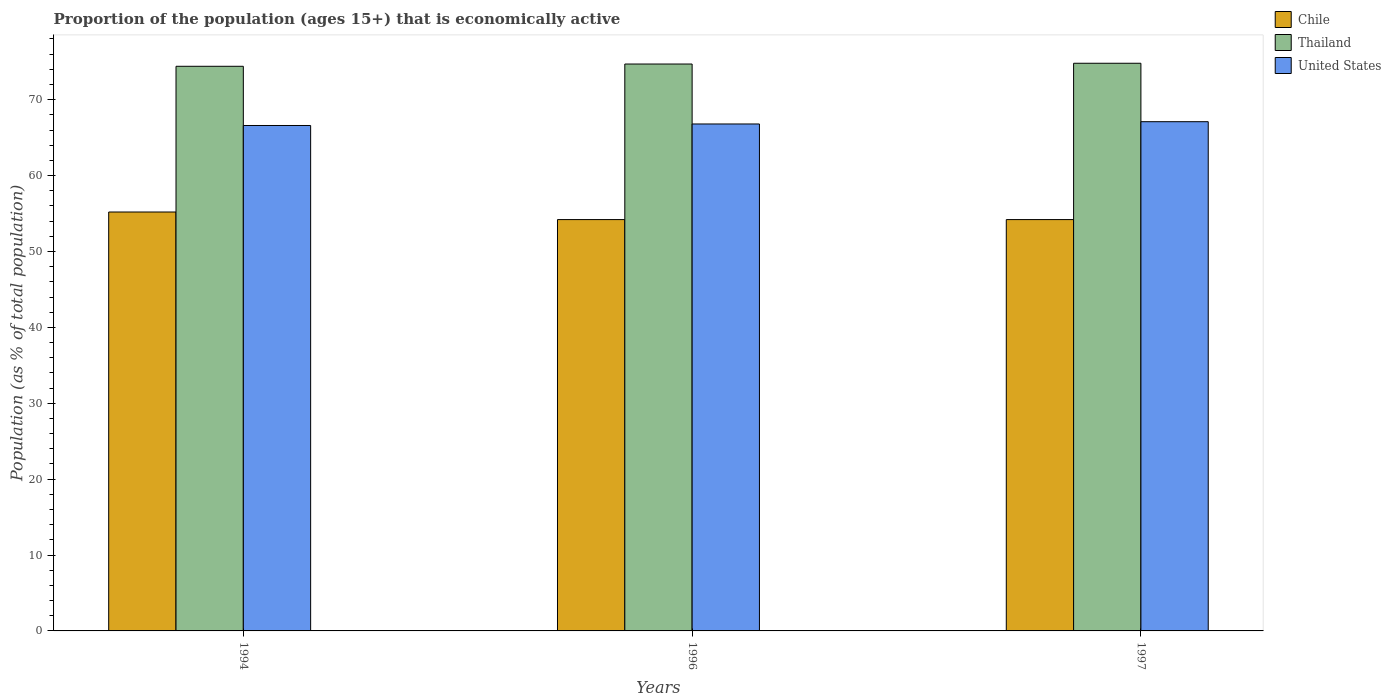How many different coloured bars are there?
Keep it short and to the point. 3. How many bars are there on the 1st tick from the left?
Offer a very short reply. 3. In how many cases, is the number of bars for a given year not equal to the number of legend labels?
Provide a succinct answer. 0. What is the proportion of the population that is economically active in Thailand in 1997?
Your response must be concise. 74.8. Across all years, what is the maximum proportion of the population that is economically active in Chile?
Your answer should be very brief. 55.2. Across all years, what is the minimum proportion of the population that is economically active in Thailand?
Provide a succinct answer. 74.4. In which year was the proportion of the population that is economically active in United States maximum?
Keep it short and to the point. 1997. In which year was the proportion of the population that is economically active in Thailand minimum?
Make the answer very short. 1994. What is the total proportion of the population that is economically active in Chile in the graph?
Offer a very short reply. 163.6. What is the difference between the proportion of the population that is economically active in United States in 1996 and that in 1997?
Give a very brief answer. -0.3. What is the difference between the proportion of the population that is economically active in Thailand in 1997 and the proportion of the population that is economically active in Chile in 1994?
Give a very brief answer. 19.6. What is the average proportion of the population that is economically active in Chile per year?
Make the answer very short. 54.53. In the year 1994, what is the difference between the proportion of the population that is economically active in Chile and proportion of the population that is economically active in Thailand?
Keep it short and to the point. -19.2. In how many years, is the proportion of the population that is economically active in United States greater than 68 %?
Provide a short and direct response. 0. Is the proportion of the population that is economically active in Chile in 1996 less than that in 1997?
Provide a succinct answer. No. What is the difference between the highest and the second highest proportion of the population that is economically active in United States?
Your answer should be very brief. 0.3. In how many years, is the proportion of the population that is economically active in Thailand greater than the average proportion of the population that is economically active in Thailand taken over all years?
Your answer should be very brief. 2. Is the sum of the proportion of the population that is economically active in Chile in 1994 and 1996 greater than the maximum proportion of the population that is economically active in United States across all years?
Make the answer very short. Yes. What does the 2nd bar from the left in 1994 represents?
Your answer should be very brief. Thailand. What does the 1st bar from the right in 1996 represents?
Ensure brevity in your answer.  United States. Is it the case that in every year, the sum of the proportion of the population that is economically active in United States and proportion of the population that is economically active in Chile is greater than the proportion of the population that is economically active in Thailand?
Make the answer very short. Yes. How many bars are there?
Give a very brief answer. 9. How many years are there in the graph?
Your answer should be compact. 3. What is the difference between two consecutive major ticks on the Y-axis?
Keep it short and to the point. 10. Are the values on the major ticks of Y-axis written in scientific E-notation?
Provide a succinct answer. No. How are the legend labels stacked?
Keep it short and to the point. Vertical. What is the title of the graph?
Offer a very short reply. Proportion of the population (ages 15+) that is economically active. Does "Channel Islands" appear as one of the legend labels in the graph?
Your answer should be very brief. No. What is the label or title of the Y-axis?
Your answer should be compact. Population (as % of total population). What is the Population (as % of total population) in Chile in 1994?
Offer a terse response. 55.2. What is the Population (as % of total population) of Thailand in 1994?
Offer a terse response. 74.4. What is the Population (as % of total population) of United States in 1994?
Provide a short and direct response. 66.6. What is the Population (as % of total population) in Chile in 1996?
Your answer should be very brief. 54.2. What is the Population (as % of total population) in Thailand in 1996?
Make the answer very short. 74.7. What is the Population (as % of total population) of United States in 1996?
Your response must be concise. 66.8. What is the Population (as % of total population) in Chile in 1997?
Your response must be concise. 54.2. What is the Population (as % of total population) in Thailand in 1997?
Provide a succinct answer. 74.8. What is the Population (as % of total population) in United States in 1997?
Offer a terse response. 67.1. Across all years, what is the maximum Population (as % of total population) in Chile?
Offer a very short reply. 55.2. Across all years, what is the maximum Population (as % of total population) in Thailand?
Keep it short and to the point. 74.8. Across all years, what is the maximum Population (as % of total population) in United States?
Make the answer very short. 67.1. Across all years, what is the minimum Population (as % of total population) of Chile?
Offer a very short reply. 54.2. Across all years, what is the minimum Population (as % of total population) of Thailand?
Offer a very short reply. 74.4. Across all years, what is the minimum Population (as % of total population) in United States?
Make the answer very short. 66.6. What is the total Population (as % of total population) of Chile in the graph?
Provide a short and direct response. 163.6. What is the total Population (as % of total population) in Thailand in the graph?
Provide a short and direct response. 223.9. What is the total Population (as % of total population) of United States in the graph?
Give a very brief answer. 200.5. What is the difference between the Population (as % of total population) in Chile in 1994 and that in 1996?
Ensure brevity in your answer.  1. What is the difference between the Population (as % of total population) of Chile in 1994 and that in 1997?
Keep it short and to the point. 1. What is the difference between the Population (as % of total population) in United States in 1994 and that in 1997?
Provide a short and direct response. -0.5. What is the difference between the Population (as % of total population) of Chile in 1996 and that in 1997?
Provide a short and direct response. 0. What is the difference between the Population (as % of total population) of Thailand in 1996 and that in 1997?
Make the answer very short. -0.1. What is the difference between the Population (as % of total population) of United States in 1996 and that in 1997?
Make the answer very short. -0.3. What is the difference between the Population (as % of total population) of Chile in 1994 and the Population (as % of total population) of Thailand in 1996?
Make the answer very short. -19.5. What is the difference between the Population (as % of total population) of Chile in 1994 and the Population (as % of total population) of Thailand in 1997?
Keep it short and to the point. -19.6. What is the difference between the Population (as % of total population) in Chile in 1994 and the Population (as % of total population) in United States in 1997?
Give a very brief answer. -11.9. What is the difference between the Population (as % of total population) in Thailand in 1994 and the Population (as % of total population) in United States in 1997?
Your answer should be compact. 7.3. What is the difference between the Population (as % of total population) in Chile in 1996 and the Population (as % of total population) in Thailand in 1997?
Offer a very short reply. -20.6. What is the difference between the Population (as % of total population) in Chile in 1996 and the Population (as % of total population) in United States in 1997?
Keep it short and to the point. -12.9. What is the difference between the Population (as % of total population) of Thailand in 1996 and the Population (as % of total population) of United States in 1997?
Keep it short and to the point. 7.6. What is the average Population (as % of total population) of Chile per year?
Make the answer very short. 54.53. What is the average Population (as % of total population) of Thailand per year?
Offer a very short reply. 74.63. What is the average Population (as % of total population) of United States per year?
Ensure brevity in your answer.  66.83. In the year 1994, what is the difference between the Population (as % of total population) of Chile and Population (as % of total population) of Thailand?
Provide a succinct answer. -19.2. In the year 1994, what is the difference between the Population (as % of total population) of Chile and Population (as % of total population) of United States?
Provide a short and direct response. -11.4. In the year 1996, what is the difference between the Population (as % of total population) in Chile and Population (as % of total population) in Thailand?
Give a very brief answer. -20.5. In the year 1996, what is the difference between the Population (as % of total population) in Chile and Population (as % of total population) in United States?
Keep it short and to the point. -12.6. In the year 1997, what is the difference between the Population (as % of total population) of Chile and Population (as % of total population) of Thailand?
Your response must be concise. -20.6. In the year 1997, what is the difference between the Population (as % of total population) in Chile and Population (as % of total population) in United States?
Your answer should be very brief. -12.9. What is the ratio of the Population (as % of total population) of Chile in 1994 to that in 1996?
Give a very brief answer. 1.02. What is the ratio of the Population (as % of total population) of Chile in 1994 to that in 1997?
Your response must be concise. 1.02. What is the ratio of the Population (as % of total population) of Chile in 1996 to that in 1997?
Your answer should be very brief. 1. What is the ratio of the Population (as % of total population) of Thailand in 1996 to that in 1997?
Offer a terse response. 1. What is the ratio of the Population (as % of total population) of United States in 1996 to that in 1997?
Your answer should be very brief. 1. What is the difference between the highest and the lowest Population (as % of total population) in Thailand?
Make the answer very short. 0.4. 